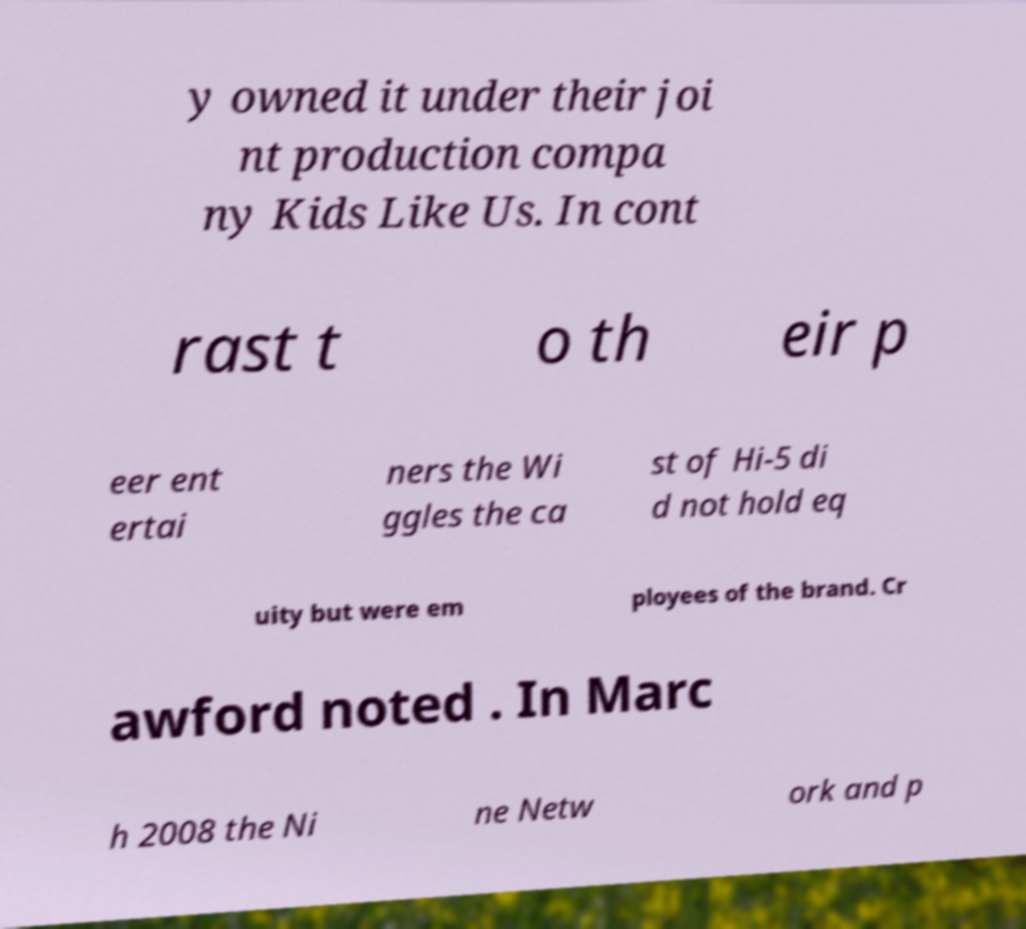Please identify and transcribe the text found in this image. y owned it under their joi nt production compa ny Kids Like Us. In cont rast t o th eir p eer ent ertai ners the Wi ggles the ca st of Hi-5 di d not hold eq uity but were em ployees of the brand. Cr awford noted . In Marc h 2008 the Ni ne Netw ork and p 